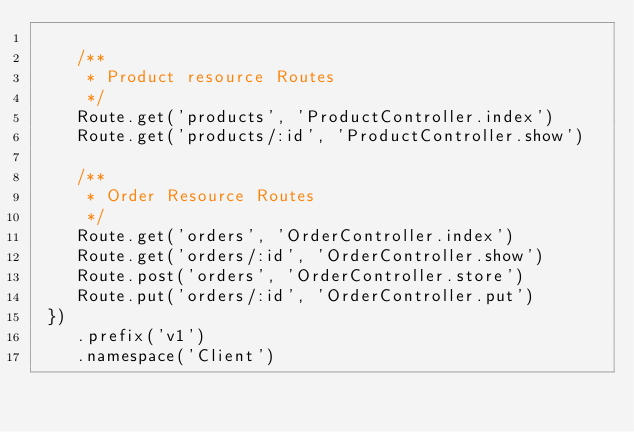Convert code to text. <code><loc_0><loc_0><loc_500><loc_500><_JavaScript_>
    /**
     * Product resource Routes
     */
    Route.get('products', 'ProductController.index')
    Route.get('products/:id', 'ProductController.show')

    /**
     * Order Resource Routes
     */
    Route.get('orders', 'OrderController.index')
    Route.get('orders/:id', 'OrderController.show')
    Route.post('orders', 'OrderController.store')
    Route.put('orders/:id', 'OrderController.put')
 })
    .prefix('v1')
    .namespace('Client')</code> 